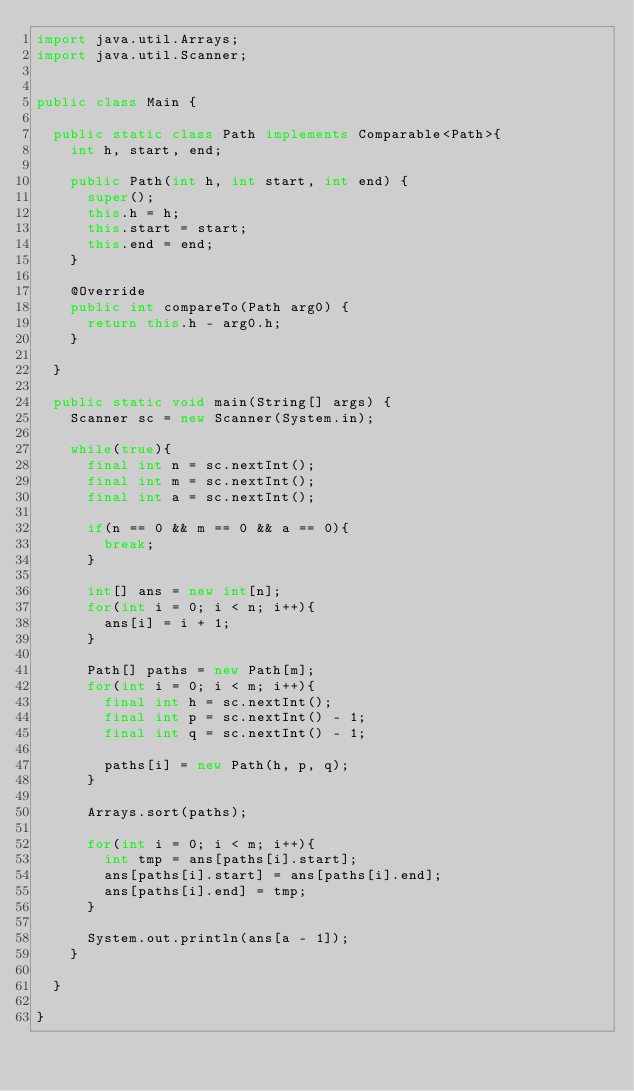Convert code to text. <code><loc_0><loc_0><loc_500><loc_500><_Java_>import java.util.Arrays;
import java.util.Scanner;


public class Main {
	
	public static class Path implements Comparable<Path>{
		int h, start, end;
		
		public Path(int h, int start, int end) {
			super();
			this.h = h;
			this.start = start;
			this.end = end;
		}

		@Override
		public int compareTo(Path arg0) {
			return this.h - arg0.h;
		}
		
	}
	
	public static void main(String[] args) {
		Scanner sc = new Scanner(System.in);
		
		while(true){
			final int n = sc.nextInt();
			final int m = sc.nextInt();
			final int a = sc.nextInt();
			
			if(n == 0 && m == 0 && a == 0){
				break;
			}
			
			int[] ans = new int[n];
			for(int i = 0; i < n; i++){
				ans[i] = i + 1;
			}
			
			Path[] paths = new Path[m];
			for(int i = 0; i < m; i++){
				final int h = sc.nextInt();
				final int p = sc.nextInt() - 1;
				final int q = sc.nextInt() - 1;
				
				paths[i] = new Path(h, p, q);
			}
			
			Arrays.sort(paths);
			
			for(int i = 0; i < m; i++){
				int tmp = ans[paths[i].start];
				ans[paths[i].start] = ans[paths[i].end];
				ans[paths[i].end] = tmp;
			}
			
			System.out.println(ans[a - 1]);
		}
		
	}

}</code> 